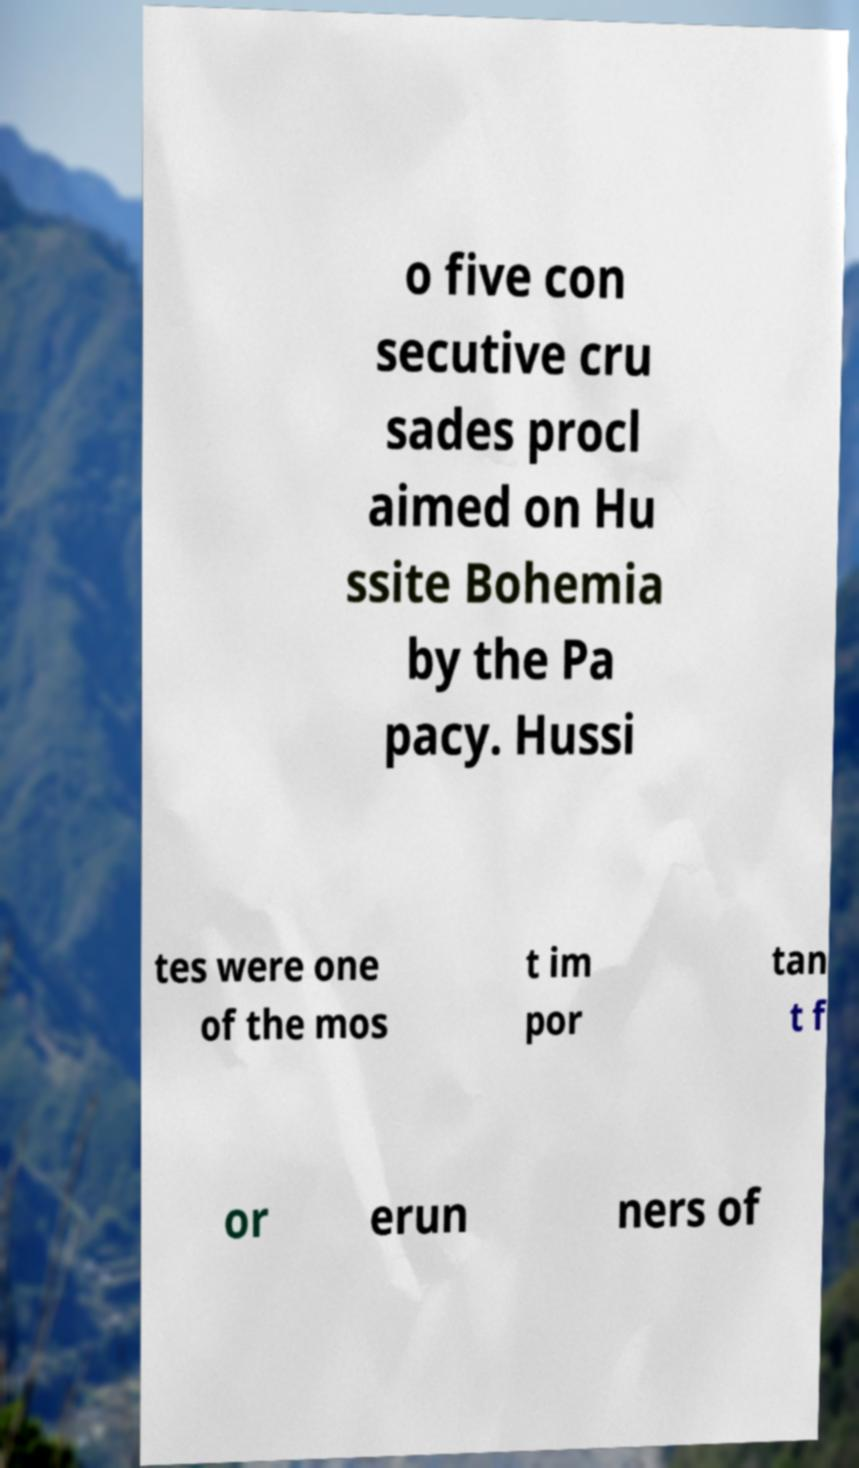I need the written content from this picture converted into text. Can you do that? o five con secutive cru sades procl aimed on Hu ssite Bohemia by the Pa pacy. Hussi tes were one of the mos t im por tan t f or erun ners of 